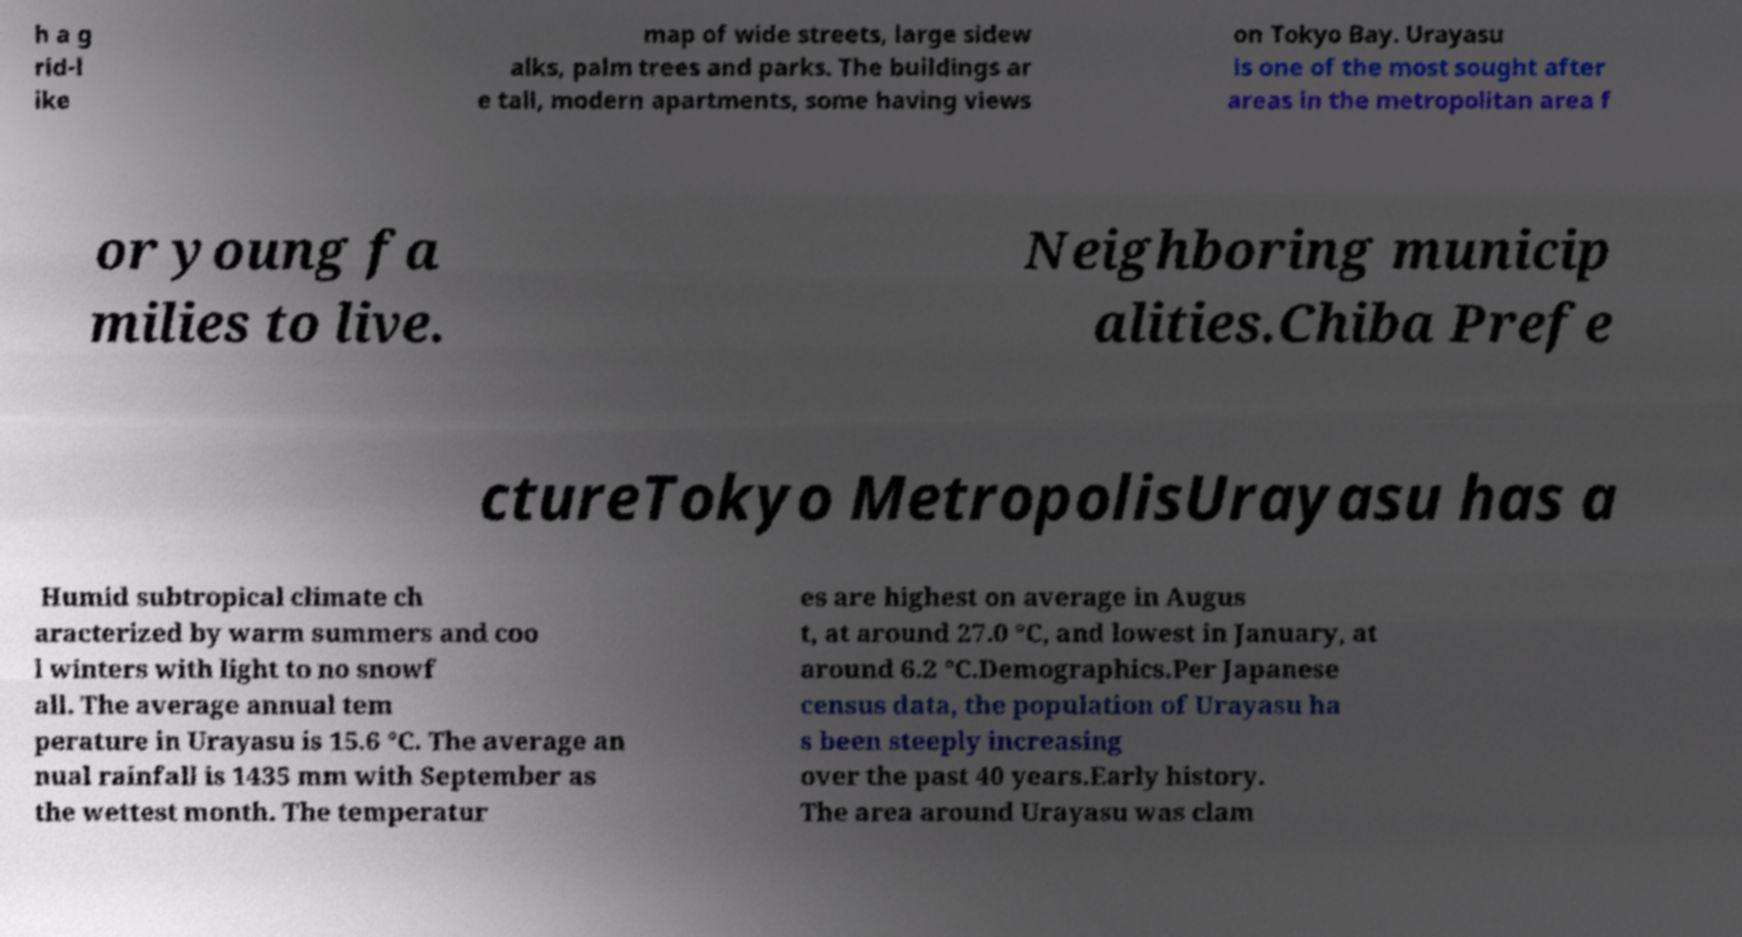Can you read and provide the text displayed in the image?This photo seems to have some interesting text. Can you extract and type it out for me? h a g rid-l ike map of wide streets, large sidew alks, palm trees and parks. The buildings ar e tall, modern apartments, some having views on Tokyo Bay. Urayasu is one of the most sought after areas in the metropolitan area f or young fa milies to live. Neighboring municip alities.Chiba Prefe ctureTokyo MetropolisUrayasu has a Humid subtropical climate ch aracterized by warm summers and coo l winters with light to no snowf all. The average annual tem perature in Urayasu is 15.6 °C. The average an nual rainfall is 1435 mm with September as the wettest month. The temperatur es are highest on average in Augus t, at around 27.0 °C, and lowest in January, at around 6.2 °C.Demographics.Per Japanese census data, the population of Urayasu ha s been steeply increasing over the past 40 years.Early history. The area around Urayasu was clam 